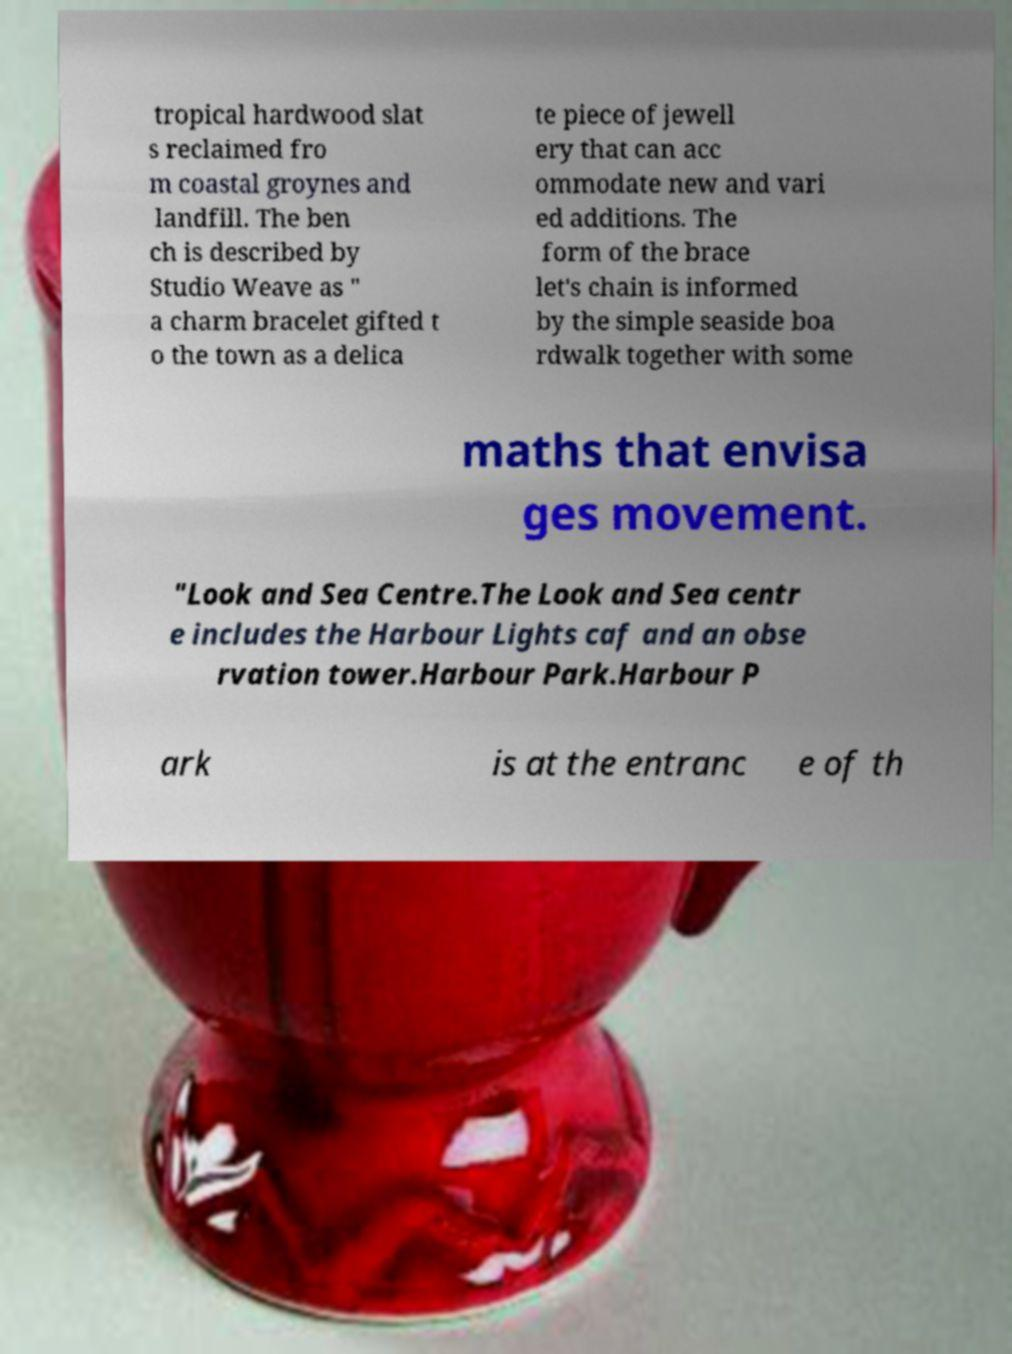There's text embedded in this image that I need extracted. Can you transcribe it verbatim? tropical hardwood slat s reclaimed fro m coastal groynes and landfill. The ben ch is described by Studio Weave as " a charm bracelet gifted t o the town as a delica te piece of jewell ery that can acc ommodate new and vari ed additions. The form of the brace let's chain is informed by the simple seaside boa rdwalk together with some maths that envisa ges movement. "Look and Sea Centre.The Look and Sea centr e includes the Harbour Lights caf and an obse rvation tower.Harbour Park.Harbour P ark is at the entranc e of th 